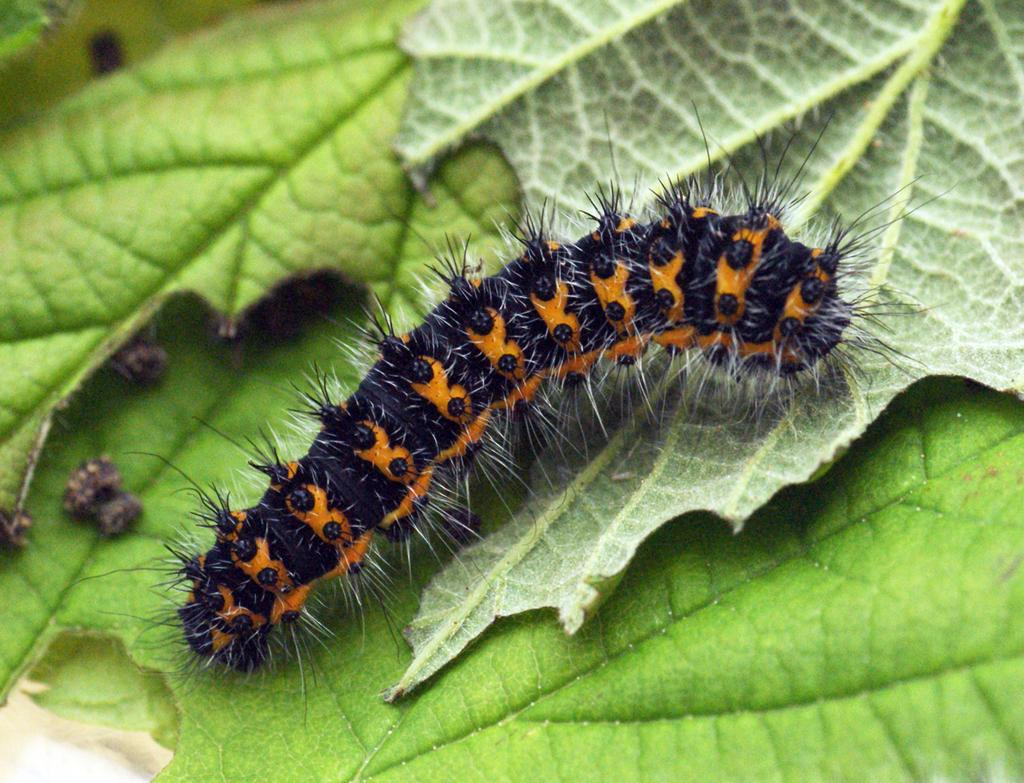What is the main subject of the image? The main subject of the image is a caterpillar. Where is the caterpillar located in the image? The caterpillar is on leaves in the image. What type of truck can be seen carrying beans in the image? There is no truck, beans, or any reference to transportation in the image. The image only features a caterpillar on leaves. 